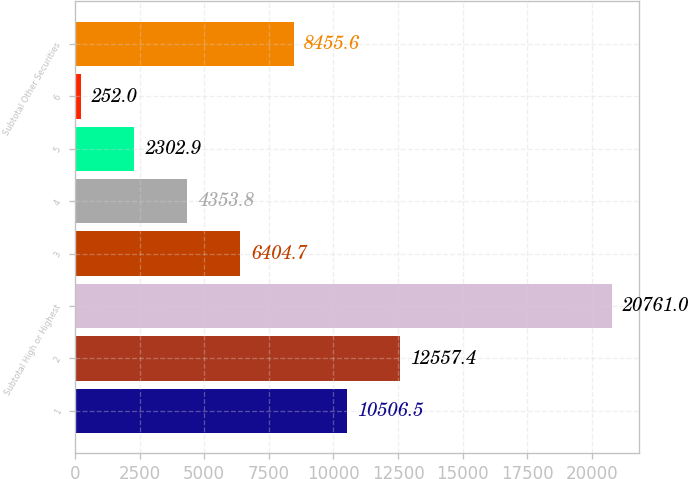Convert chart. <chart><loc_0><loc_0><loc_500><loc_500><bar_chart><fcel>1<fcel>2<fcel>Subtotal High or Highest<fcel>3<fcel>4<fcel>5<fcel>6<fcel>Subtotal Other Securities<nl><fcel>10506.5<fcel>12557.4<fcel>20761<fcel>6404.7<fcel>4353.8<fcel>2302.9<fcel>252<fcel>8455.6<nl></chart> 